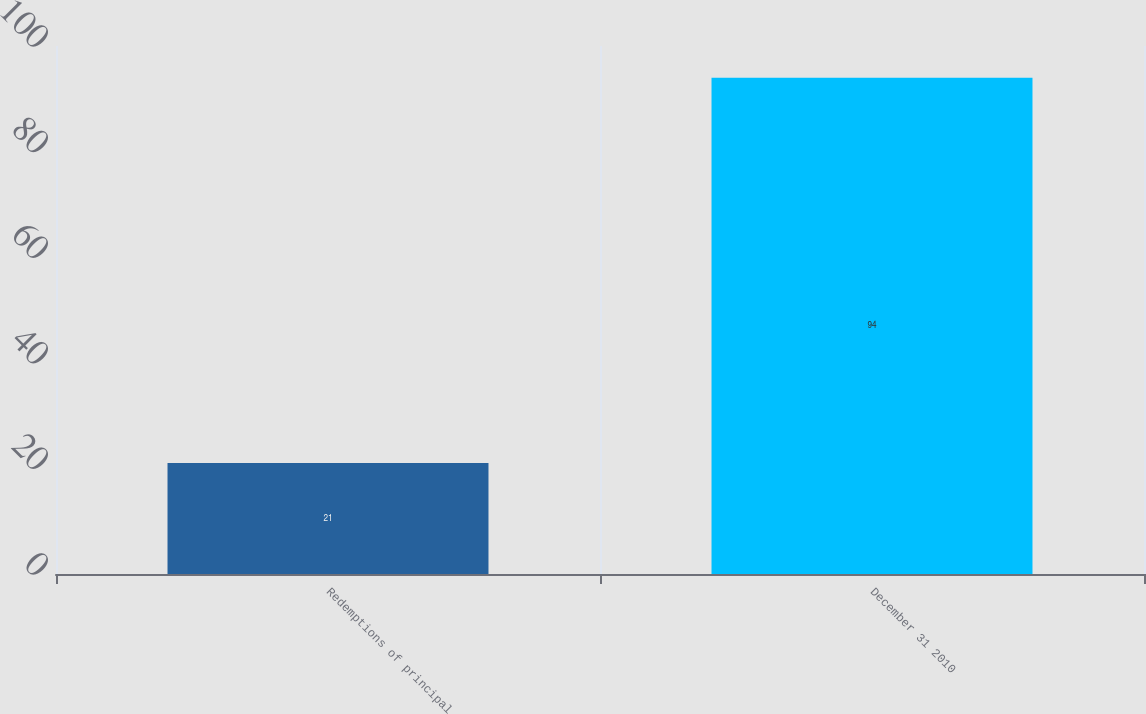Convert chart. <chart><loc_0><loc_0><loc_500><loc_500><bar_chart><fcel>Redemptions of principal<fcel>December 31 2010<nl><fcel>21<fcel>94<nl></chart> 